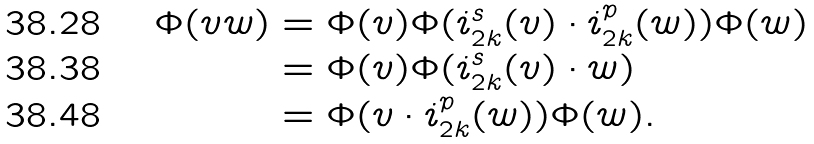Convert formula to latex. <formula><loc_0><loc_0><loc_500><loc_500>\Phi ( v w ) & = \Phi ( v ) \Phi ( i _ { 2 k } ^ { s } ( v ) \cdot i _ { 2 k } ^ { p } ( w ) ) \Phi ( w ) \\ & = \Phi ( v ) \Phi ( i _ { 2 k } ^ { s } ( v ) \cdot w ) \\ & = \Phi ( v \cdot i _ { 2 k } ^ { p } ( w ) ) \Phi ( w ) .</formula> 